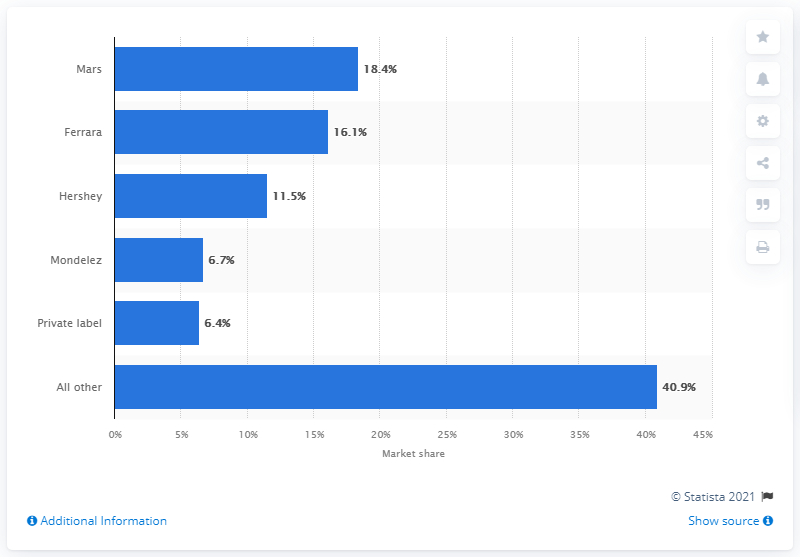Indicate a few pertinent items in this graphic. According to Mars' 2018 financial report, non-chocolate sales accounted for 18.4% of their overall revenue. In 2018, Mars had a market share of 18.4 percent of non-chocolate sales in the United States. 